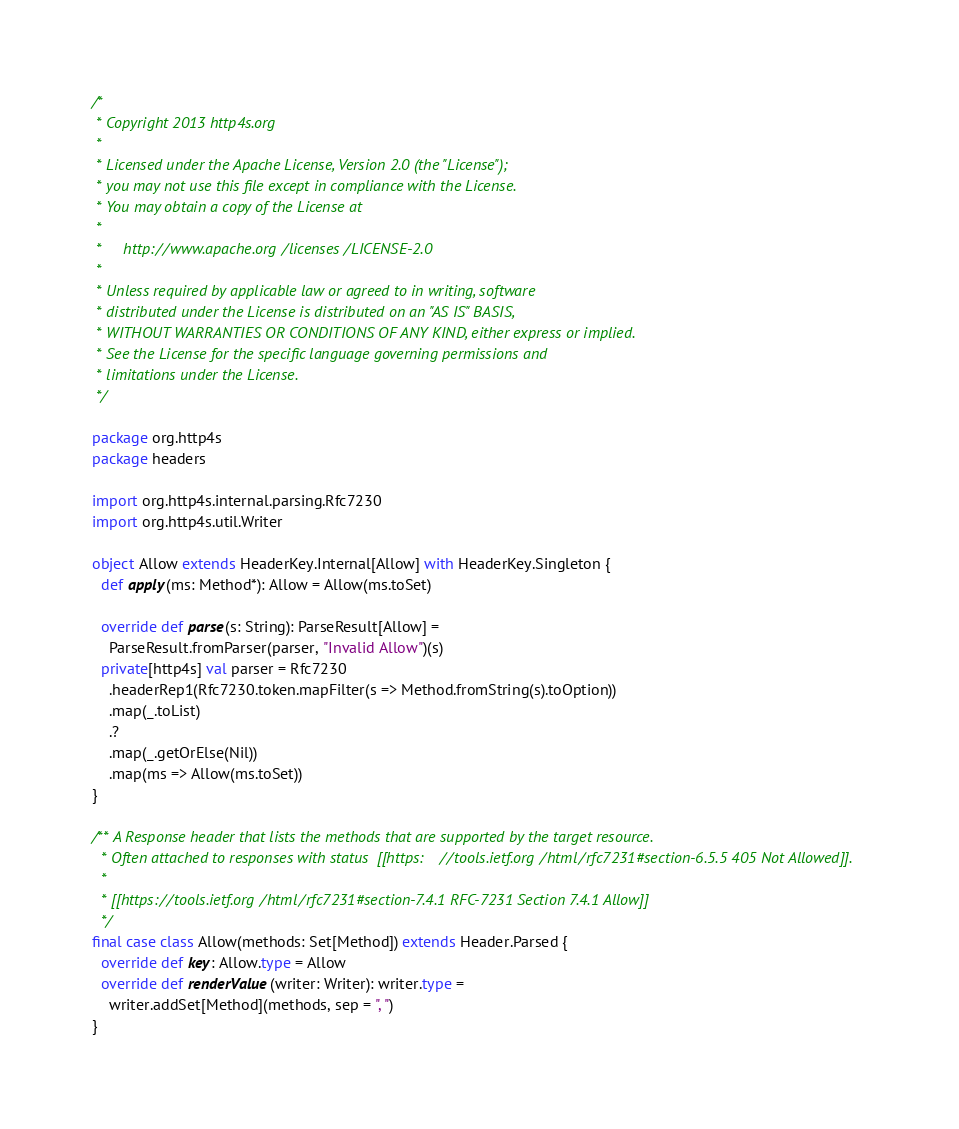<code> <loc_0><loc_0><loc_500><loc_500><_Scala_>/*
 * Copyright 2013 http4s.org
 *
 * Licensed under the Apache License, Version 2.0 (the "License");
 * you may not use this file except in compliance with the License.
 * You may obtain a copy of the License at
 *
 *     http://www.apache.org/licenses/LICENSE-2.0
 *
 * Unless required by applicable law or agreed to in writing, software
 * distributed under the License is distributed on an "AS IS" BASIS,
 * WITHOUT WARRANTIES OR CONDITIONS OF ANY KIND, either express or implied.
 * See the License for the specific language governing permissions and
 * limitations under the License.
 */

package org.http4s
package headers

import org.http4s.internal.parsing.Rfc7230
import org.http4s.util.Writer

object Allow extends HeaderKey.Internal[Allow] with HeaderKey.Singleton {
  def apply(ms: Method*): Allow = Allow(ms.toSet)

  override def parse(s: String): ParseResult[Allow] =
    ParseResult.fromParser(parser, "Invalid Allow")(s)
  private[http4s] val parser = Rfc7230
    .headerRep1(Rfc7230.token.mapFilter(s => Method.fromString(s).toOption))
    .map(_.toList)
    .?
    .map(_.getOrElse(Nil))
    .map(ms => Allow(ms.toSet))
}

/** A Response header that lists the methods that are supported by the target resource.
  * Often attached to responses with status  [[https://tools.ietf.org/html/rfc7231#section-6.5.5 405 Not Allowed]].
  *
  * [[https://tools.ietf.org/html/rfc7231#section-7.4.1 RFC-7231 Section 7.4.1 Allow]]
  */
final case class Allow(methods: Set[Method]) extends Header.Parsed {
  override def key: Allow.type = Allow
  override def renderValue(writer: Writer): writer.type =
    writer.addSet[Method](methods, sep = ", ")
}
</code> 